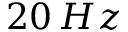<formula> <loc_0><loc_0><loc_500><loc_500>2 0 \, H z</formula> 